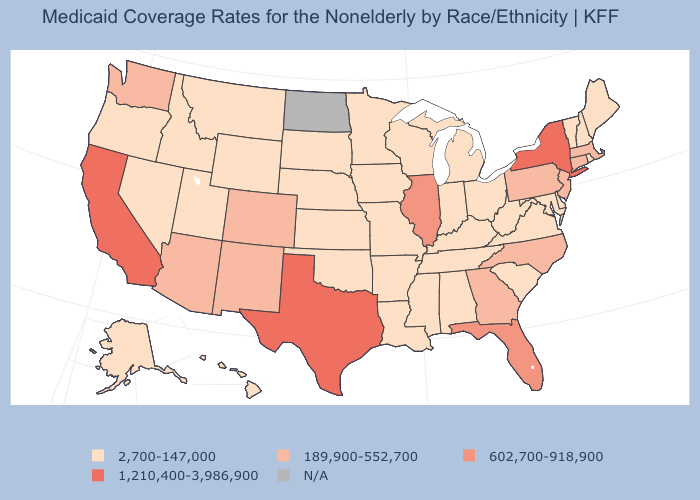Which states have the highest value in the USA?
Short answer required. California, New York, Texas. What is the value of Georgia?
Give a very brief answer. 189,900-552,700. Which states hav the highest value in the West?
Write a very short answer. California. What is the value of Maine?
Answer briefly. 2,700-147,000. Name the states that have a value in the range 2,700-147,000?
Give a very brief answer. Alabama, Alaska, Arkansas, Delaware, Hawaii, Idaho, Indiana, Iowa, Kansas, Kentucky, Louisiana, Maine, Maryland, Michigan, Minnesota, Mississippi, Missouri, Montana, Nebraska, Nevada, New Hampshire, Ohio, Oklahoma, Oregon, Rhode Island, South Carolina, South Dakota, Tennessee, Utah, Vermont, Virginia, West Virginia, Wisconsin, Wyoming. Name the states that have a value in the range 189,900-552,700?
Give a very brief answer. Arizona, Colorado, Connecticut, Georgia, Massachusetts, New Jersey, New Mexico, North Carolina, Pennsylvania, Washington. What is the highest value in the South ?
Concise answer only. 1,210,400-3,986,900. What is the value of North Carolina?
Concise answer only. 189,900-552,700. What is the value of West Virginia?
Quick response, please. 2,700-147,000. Among the states that border Washington , which have the highest value?
Keep it brief. Idaho, Oregon. Which states have the lowest value in the USA?
Write a very short answer. Alabama, Alaska, Arkansas, Delaware, Hawaii, Idaho, Indiana, Iowa, Kansas, Kentucky, Louisiana, Maine, Maryland, Michigan, Minnesota, Mississippi, Missouri, Montana, Nebraska, Nevada, New Hampshire, Ohio, Oklahoma, Oregon, Rhode Island, South Carolina, South Dakota, Tennessee, Utah, Vermont, Virginia, West Virginia, Wisconsin, Wyoming. Is the legend a continuous bar?
Give a very brief answer. No. What is the value of Maryland?
Keep it brief. 2,700-147,000. Is the legend a continuous bar?
Write a very short answer. No. 